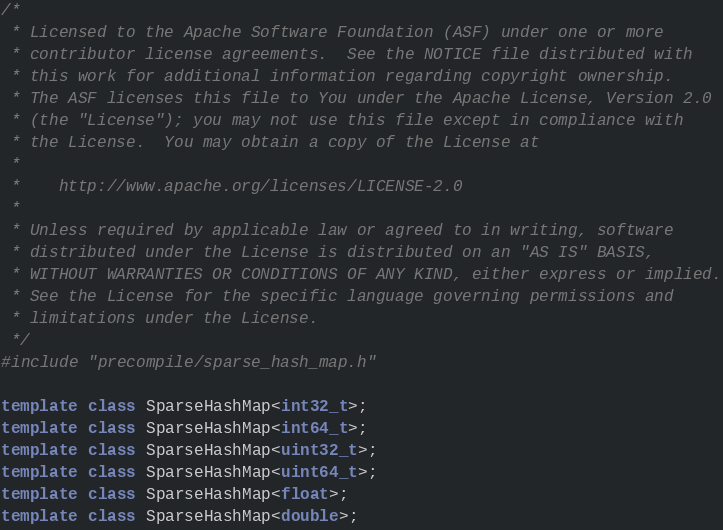Convert code to text. <code><loc_0><loc_0><loc_500><loc_500><_C++_>/*
 * Licensed to the Apache Software Foundation (ASF) under one or more
 * contributor license agreements.  See the NOTICE file distributed with
 * this work for additional information regarding copyright ownership.
 * The ASF licenses this file to You under the Apache License, Version 2.0
 * (the "License"); you may not use this file except in compliance with
 * the License.  You may obtain a copy of the License at
 *
 *    http://www.apache.org/licenses/LICENSE-2.0
 *
 * Unless required by applicable law or agreed to in writing, software
 * distributed under the License is distributed on an "AS IS" BASIS,
 * WITHOUT WARRANTIES OR CONDITIONS OF ANY KIND, either express or implied.
 * See the License for the specific language governing permissions and
 * limitations under the License.
 */
#include "precompile/sparse_hash_map.h"

template class SparseHashMap<int32_t>;
template class SparseHashMap<int64_t>;
template class SparseHashMap<uint32_t>;
template class SparseHashMap<uint64_t>;
template class SparseHashMap<float>;
template class SparseHashMap<double>;
</code> 